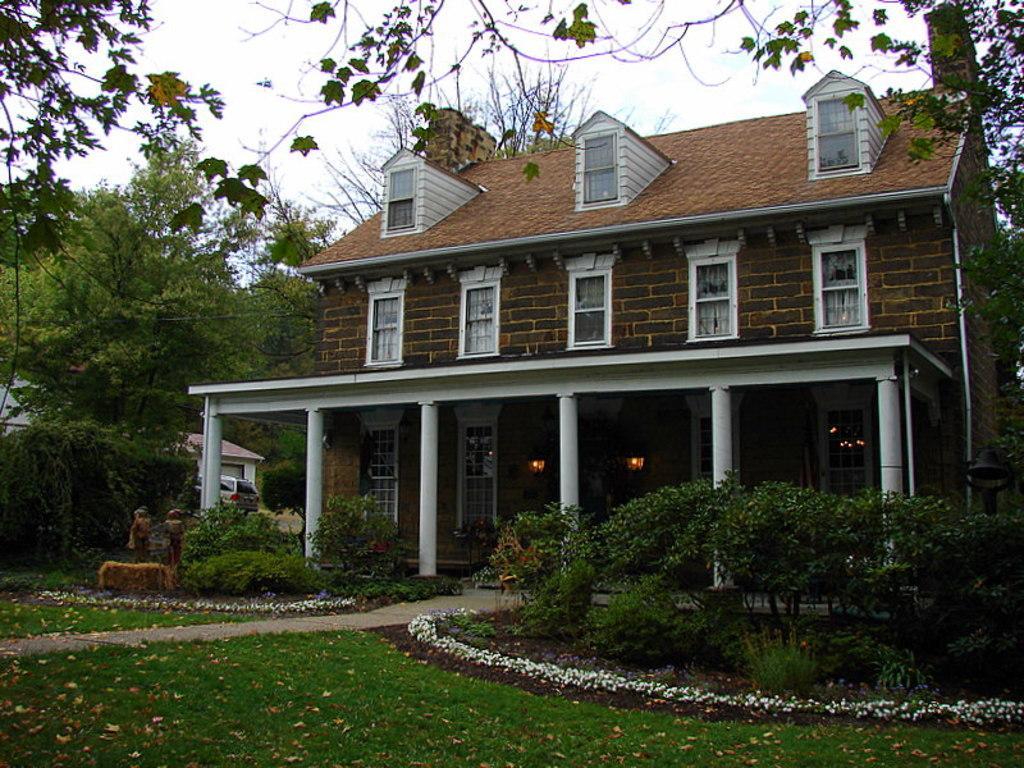Please provide a concise description of this image. In this picture we can observe a building which is in brown color. There are some windows. There is some grass on the ground. There are some plants and trees. In the background there is a sky. 